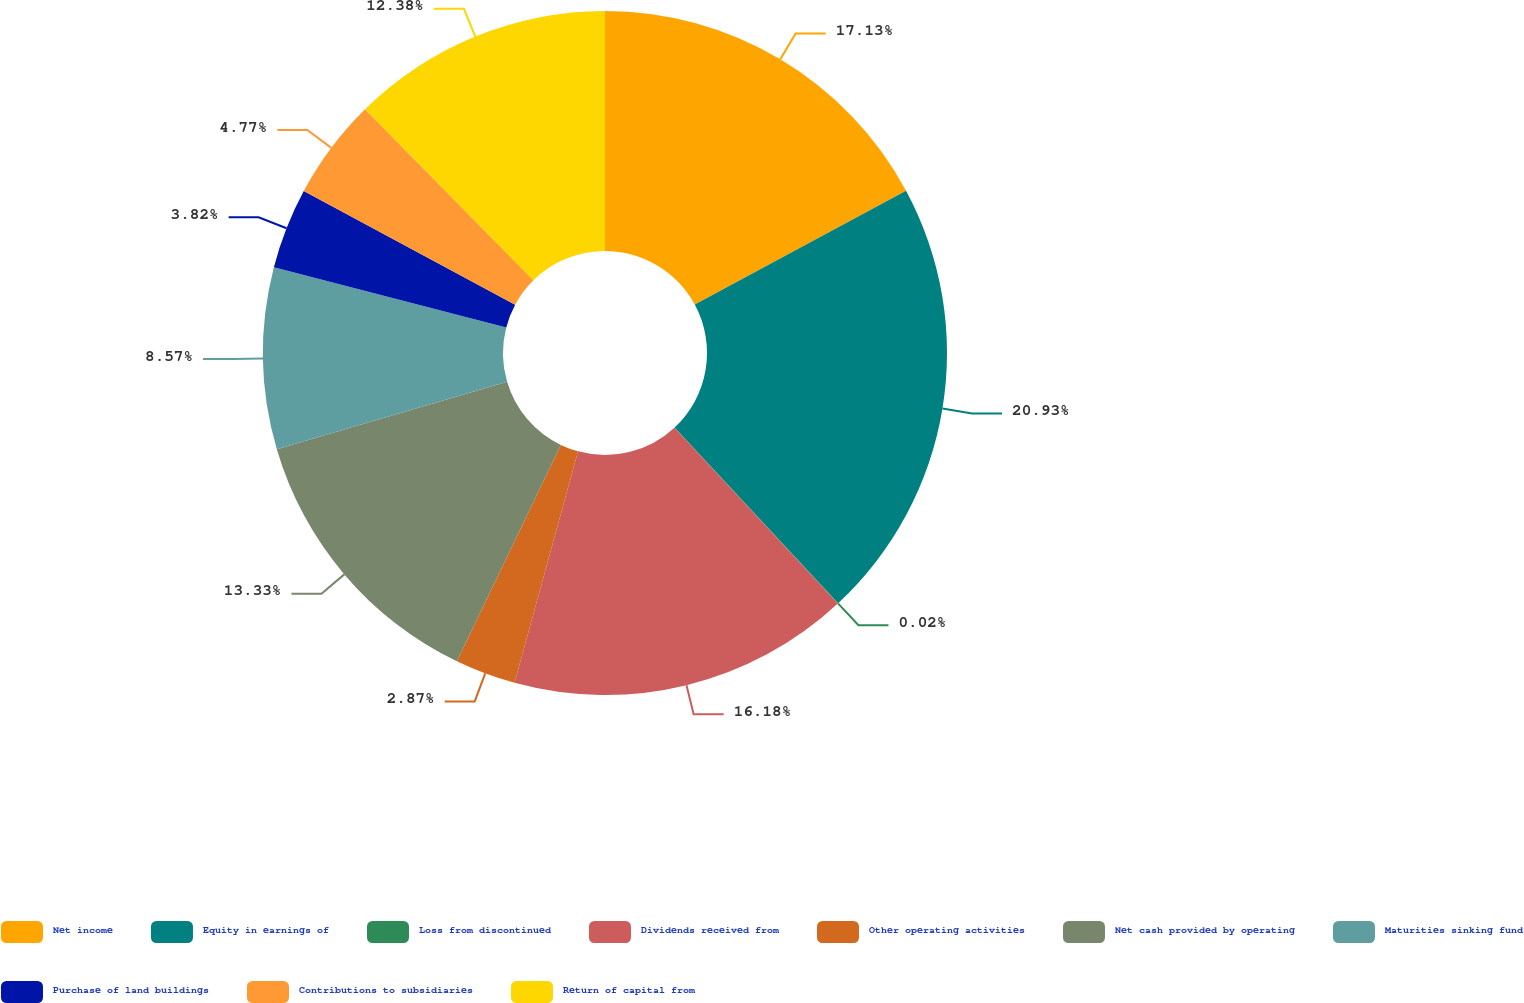Convert chart. <chart><loc_0><loc_0><loc_500><loc_500><pie_chart><fcel>Net income<fcel>Equity in earnings of<fcel>Loss from discontinued<fcel>Dividends received from<fcel>Other operating activities<fcel>Net cash provided by operating<fcel>Maturities sinking fund<fcel>Purchase of land buildings<fcel>Contributions to subsidiaries<fcel>Return of capital from<nl><fcel>17.13%<fcel>20.93%<fcel>0.02%<fcel>16.18%<fcel>2.87%<fcel>13.33%<fcel>8.57%<fcel>3.82%<fcel>4.77%<fcel>12.38%<nl></chart> 